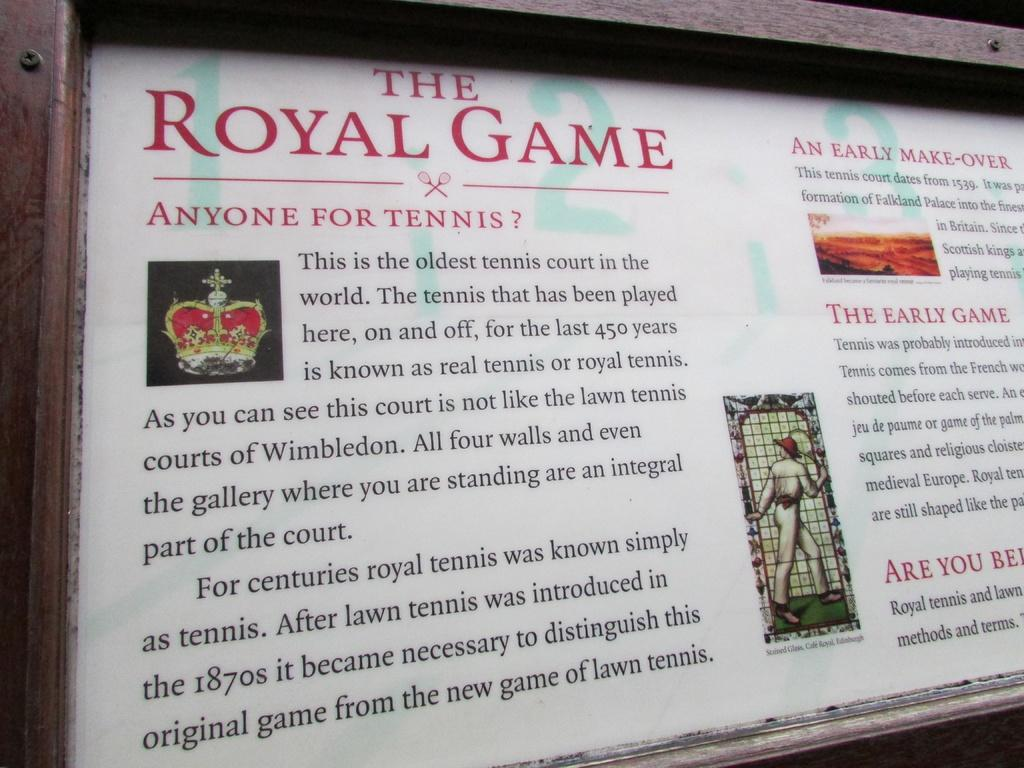<image>
Summarize the visual content of the image. a plaque about The Royal Game with a crown on it 